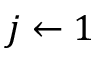<formula> <loc_0><loc_0><loc_500><loc_500>j \leftarrow 1</formula> 